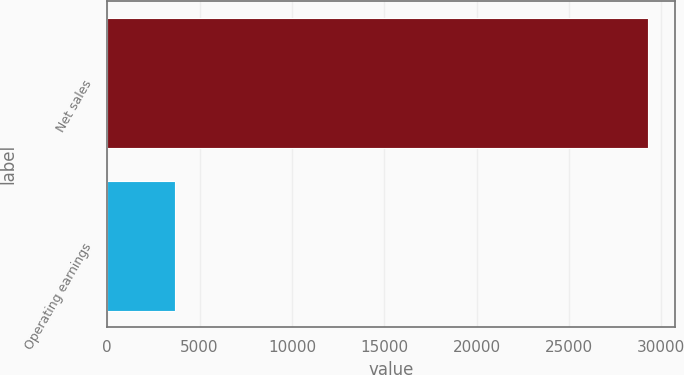Convert chart to OTSL. <chart><loc_0><loc_0><loc_500><loc_500><bar_chart><fcel>Net sales<fcel>Operating earnings<nl><fcel>29300<fcel>3653<nl></chart> 